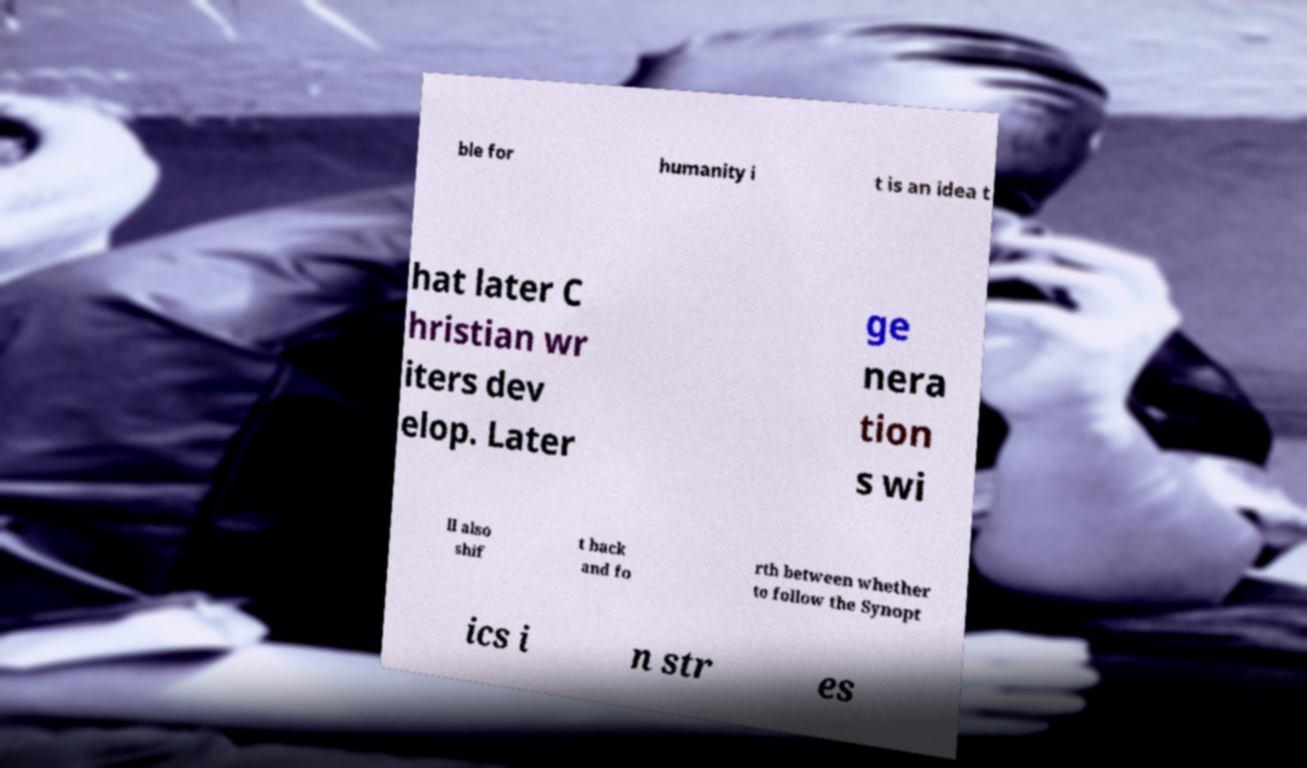Can you accurately transcribe the text from the provided image for me? ble for humanity i t is an idea t hat later C hristian wr iters dev elop. Later ge nera tion s wi ll also shif t back and fo rth between whether to follow the Synopt ics i n str es 